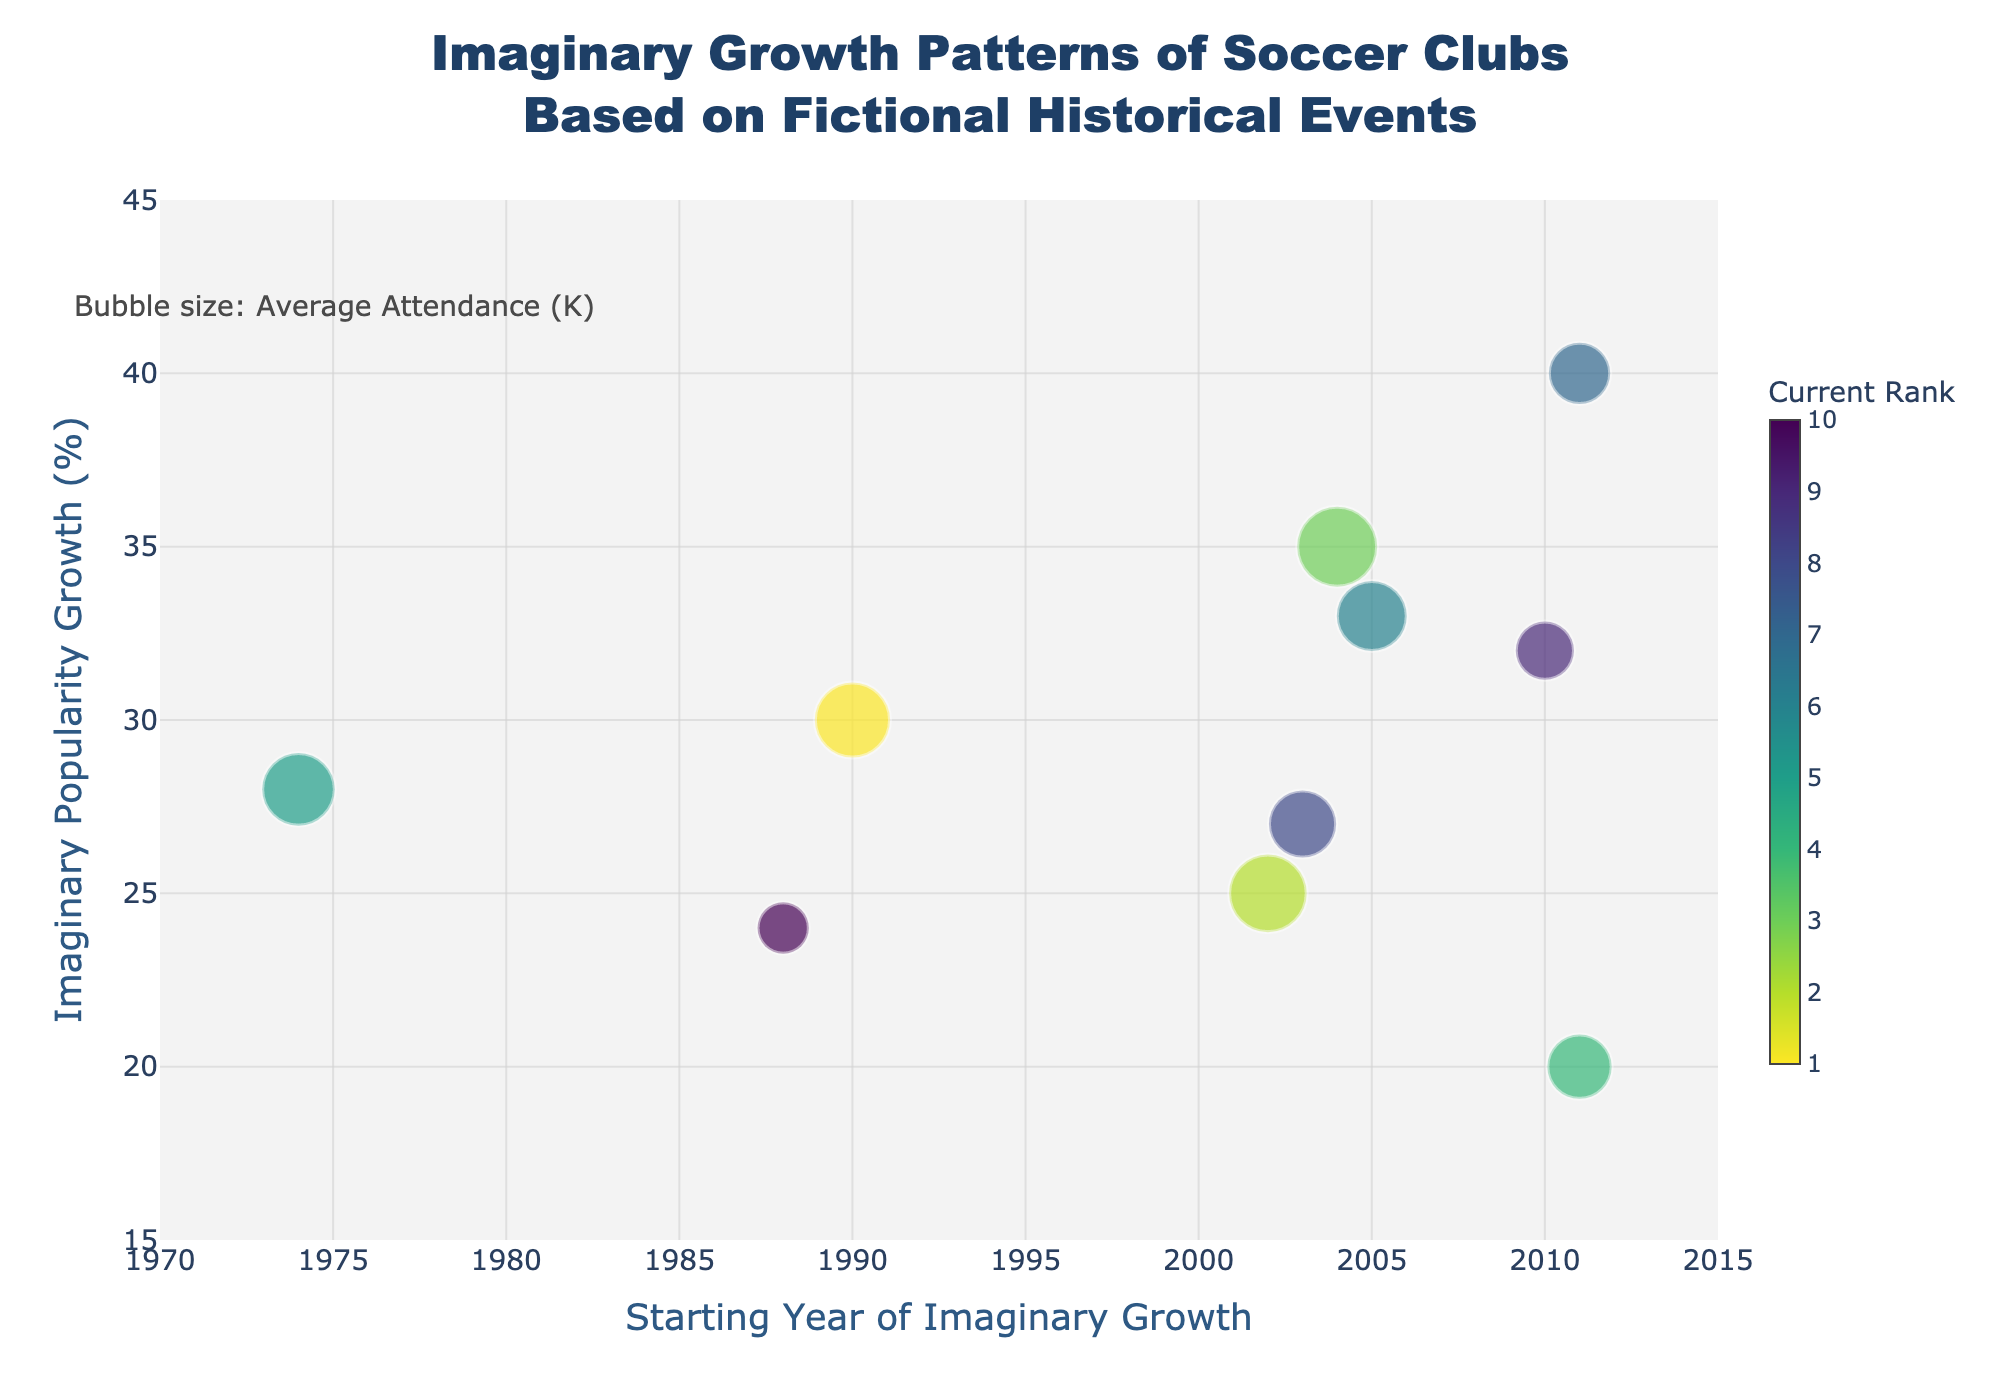what is the title of the chart? The title of the chart is usually at the top of the figure. In this case, it reads "Imaginary Growth Patterns of Soccer Clubs Based on Fictional Historical Events".
Answer: Imaginary Growth Patterns of Soccer Clubs Based on Fictional Historical Events which soccer club has the highest average attendance? From the bubbles in the chart, you can check the text annotation or the bubble sizes. Barcelona has the largest bubble size indicating the highest average attendance of 85K.
Answer: Barcelona what is the range of the x-axis in the chart? The x-axis represents the years and the range is given by the minimum and maximum values on the axis. The range is from 1970 to 2015.
Answer: 1970 to 2015 compare the popularity growth of Barcelona and Real Madrid. Which one is higher? We find the y-axis values for both clubs. Barcelona has a popularity growth of 35%, whereas Real Madrid has 25%. 35% is higher than 25%.
Answer: Barcelona which club has the earliest starting year for its imaginary growth? Check the x-axis for the earliest year represented by the bubbles. Bayern Munich, starting in 1974, is the earliest.
Answer: Bayern Munich what's the total imaginary popularity growth percentage for AC Milan and Juventus? Look at the y-axis values of both clubs. AC Milan has 24%, and Juventus has 20%. Sum them: 24% + 20% = 44%.
Answer: 44% how many clubs have an average attendance of 50K or higher? Look at the bubble sizes and identify those with average attendance at or above 50K. There are 6 clubs: Manchester United, Real Madrid, Barcelona, Bayern Munich, Liverpool, and Paris Saint-Germain.
Answer: 6 which club has the most mystical-sounding event and what rank is it? This is subjective, but one plausible choice is Borussia Dortmund with “Youth academy run by wizard”. Borussia Dortmund’s fictional rank is 9.
Answer: Borussia Dortmund, 9 identify the club with the smallest average attendance and indicate its current fictional rank. Check the smallest bubble size. AC Milan has the smallest average attendance of 35K and a current fictional rank of 10.
Answer: AC Milan, 10 